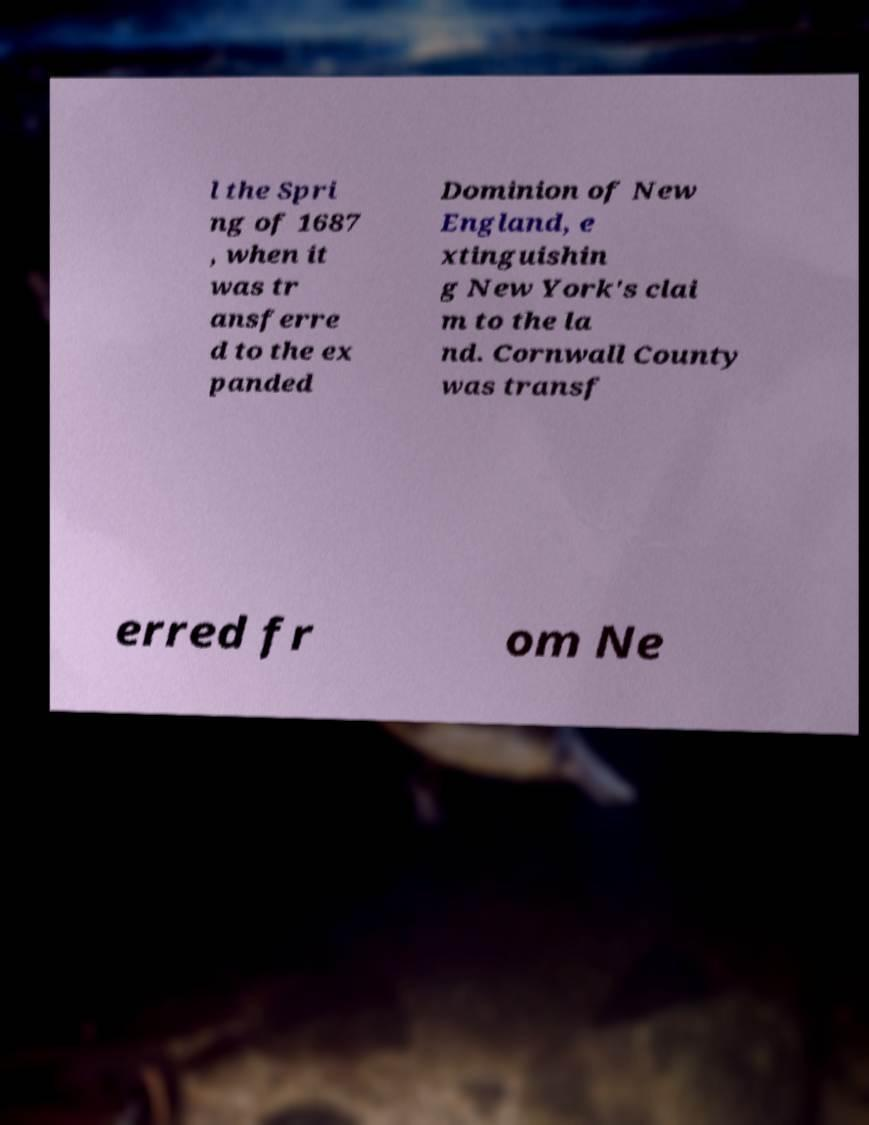Please read and relay the text visible in this image. What does it say? l the Spri ng of 1687 , when it was tr ansferre d to the ex panded Dominion of New England, e xtinguishin g New York's clai m to the la nd. Cornwall County was transf erred fr om Ne 